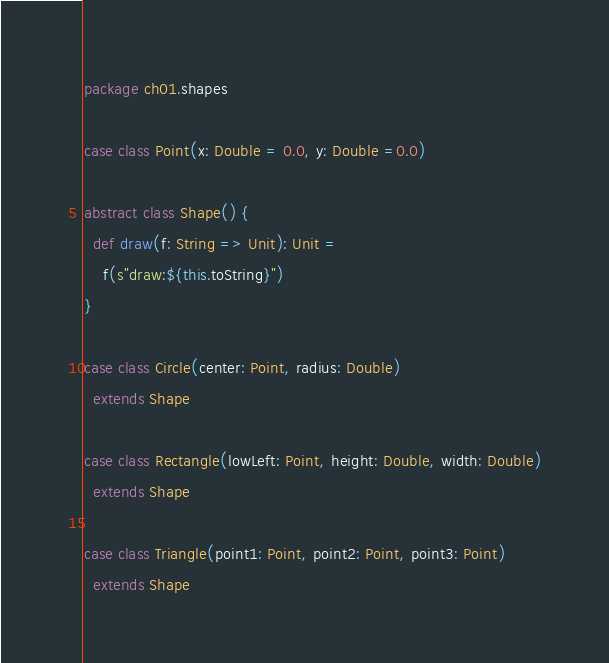<code> <loc_0><loc_0><loc_500><loc_500><_Scala_>package ch01.shapes

case class Point(x: Double = 0.0, y: Double =0.0)

abstract class Shape() {
  def draw(f: String => Unit): Unit =
    f(s"draw:${this.toString}")
}

case class Circle(center: Point, radius: Double)
  extends Shape

case class Rectangle(lowLeft: Point, height: Double, width: Double)
  extends Shape

case class Triangle(point1: Point, point2: Point, point3: Point)
  extends Shape
</code> 